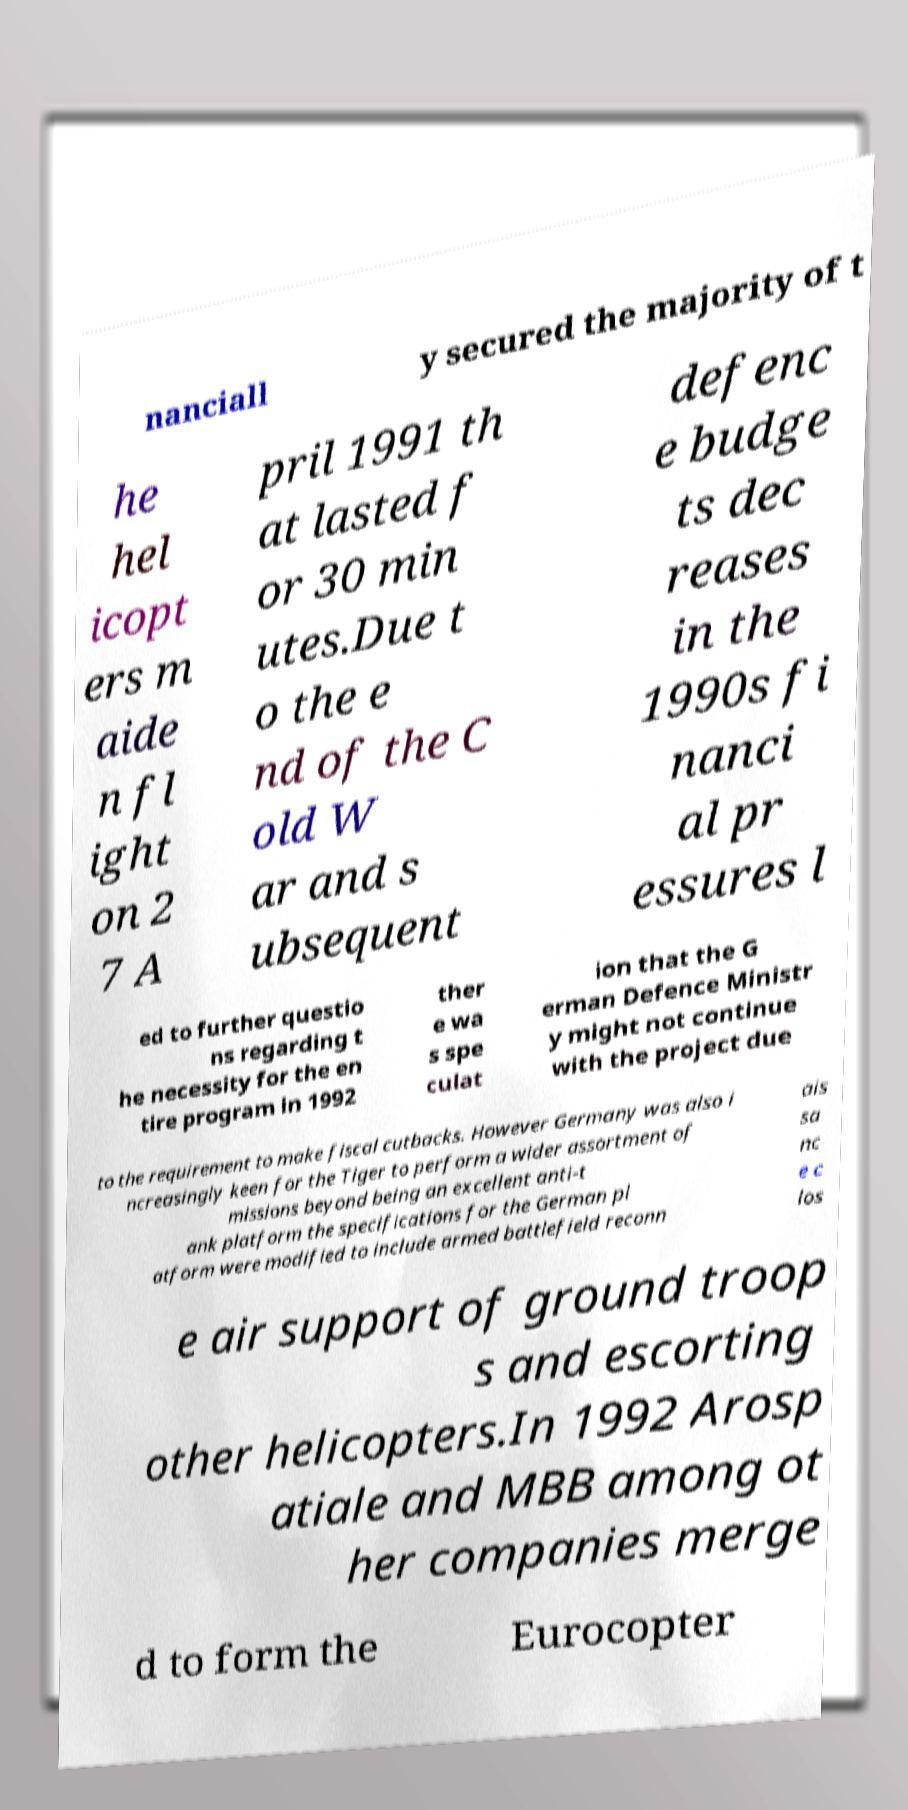There's text embedded in this image that I need extracted. Can you transcribe it verbatim? nanciall y secured the majority of t he hel icopt ers m aide n fl ight on 2 7 A pril 1991 th at lasted f or 30 min utes.Due t o the e nd of the C old W ar and s ubsequent defenc e budge ts dec reases in the 1990s fi nanci al pr essures l ed to further questio ns regarding t he necessity for the en tire program in 1992 ther e wa s spe culat ion that the G erman Defence Ministr y might not continue with the project due to the requirement to make fiscal cutbacks. However Germany was also i ncreasingly keen for the Tiger to perform a wider assortment of missions beyond being an excellent anti-t ank platform the specifications for the German pl atform were modified to include armed battlefield reconn ais sa nc e c los e air support of ground troop s and escorting other helicopters.In 1992 Arosp atiale and MBB among ot her companies merge d to form the Eurocopter 